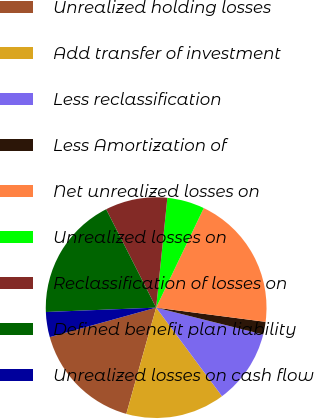Convert chart to OTSL. <chart><loc_0><loc_0><loc_500><loc_500><pie_chart><fcel>Unrealized holding losses<fcel>Add transfer of investment<fcel>Less reclassification<fcel>Less Amortization of<fcel>Net unrealized losses on<fcel>Unrealized losses on<fcel>Reclassification of losses on<fcel>Defined benefit plan liability<fcel>Unrealized losses on cash flow<nl><fcel>16.34%<fcel>14.53%<fcel>10.91%<fcel>1.86%<fcel>19.96%<fcel>5.48%<fcel>9.1%<fcel>18.15%<fcel>3.67%<nl></chart> 